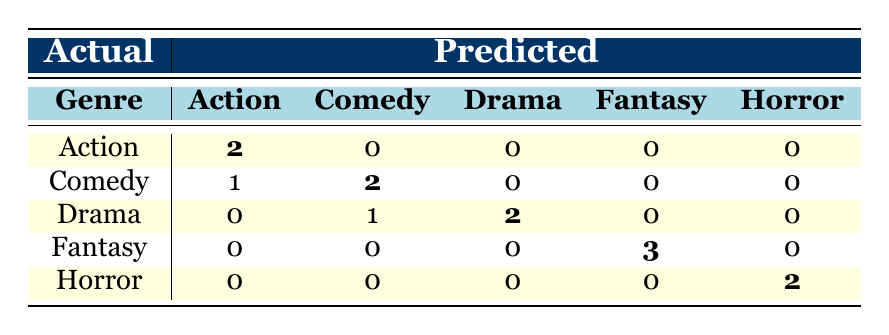What is the number of genres for which recommendations were completely accurate? In the confusion matrix, recommendations were completely accurate for the genres "Action," "Comedy," "Drama," "Fantasy," and "Horror." The diagonal values (Action: 2, Comedy: 2, Drama: 2, Fantasy: 3, Horror: 2) indicate complete accuracy by showing the predicted matches perfectly aligned with the actual genres. Thus, there are four genres with perfect recommendations: Action, Comedy, Drama, Fantasy, and Horror.
Answer: 5 How many Action movies were incorrectly recommended as Comedy? According to the confusion matrix, there is 1 movie in the Action genre that was incorrectly recommended as Comedy, as shown in the row for Action where 1 is noted under the Comedy column.
Answer: 1 What is the total number of Horror movies that were accurately recommended? The matrix shows that 2 Horror movies were correctly predicted as Horror. Since the diagonal value for Horror is 2, the total number of accurately recommended Horror movies is simply this diagonal value.
Answer: 2 Which genre had the highest accuracy in recommendations, and what was the accuracy score? By comparing the values in the diagonal of the confusion matrix, Fantasy has the highest accuracy with 3 accurate predictions out of 3 actual films in that genre. The accuracy score is calculated as 3/3, which equals 100%.
Answer: Fantasy, 100% What is the total number of Drama movies recommended across all genres? To find the total number of Drama movies recommended, we need to sum the values in the Drama column of the confusion matrix: 0 (Action) + 1 (Comedy) + 2 (Drama) + 0 (Fantasy) + 0 (Horror) = 3. Therefore, a total of 3 Drama movies were recommended across all genres.
Answer: 3 Is it true that no Fantasy movies were incorrectly recommended as Action? In the confusion matrix, the row for Fantasy shows that the value under the Action column is 0. This indicates that no Fantasy movies were recommended as Action, making the statement true.
Answer: Yes How many Comedy films were incorrectly placed as Action? From the confusion matrix, the row for Comedy indicates that there is a value of 1 under the Action column, which means that 1 Comedy film was incorrectly placed as Action.
Answer: 1 What is the sum of all incorrectly recommended films across all genres? To calculate the total number of incorrectly recommended films, sum the non-diagonal values in each row: Action (0) + Comedy (1) + Drama (1) + Fantasy (0) + Horror (0), which equals 2. Therefore, the sum of all incorrectly recommended films is 2.
Answer: 2 In how many genres were there more recommendations than actual films? By comparing the total recommendations (the sum of all values in each column) to the actual films (the sum of the diagonal), we find that for genres Action, Comedy, Drama, and Horror, the recommendations exceed the actual films. The calculations show Action (5, 3), Comedy (3, 3), Drama (3, 3), Fantasy (3, 3), and Horror (2, 3). Therefore, there are 4 genres where recommendations exceeded actual films.
Answer: 4 